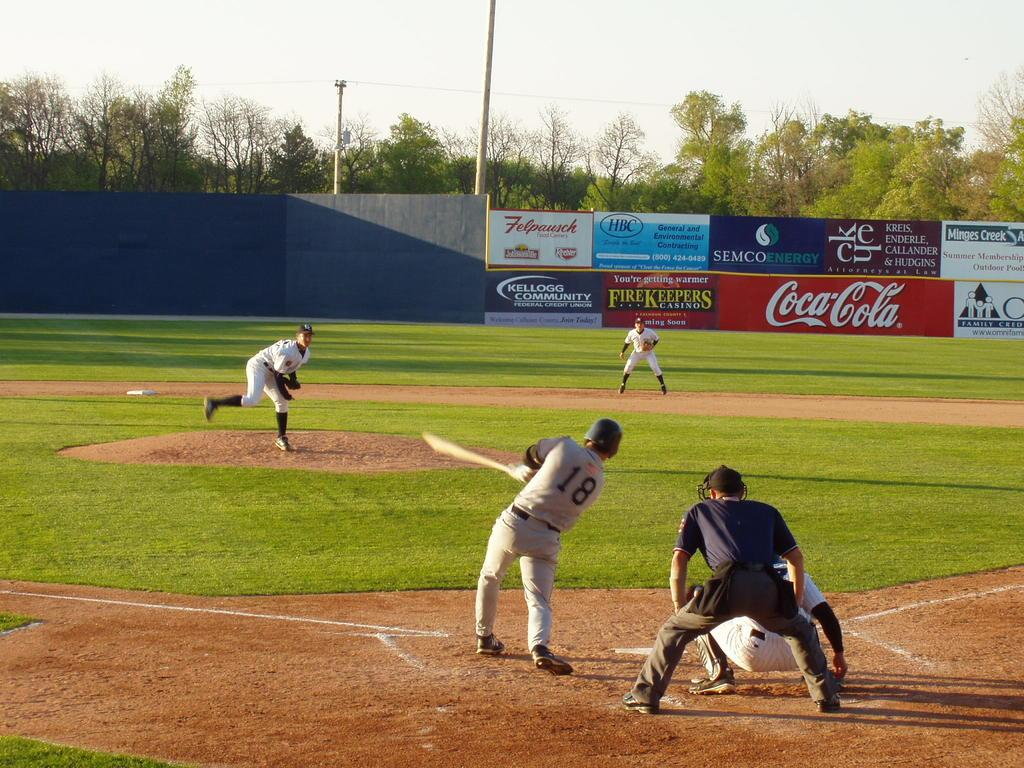<image>
Present a compact description of the photo's key features. teams playing on a baseball field sponsored by cocoa-cola 